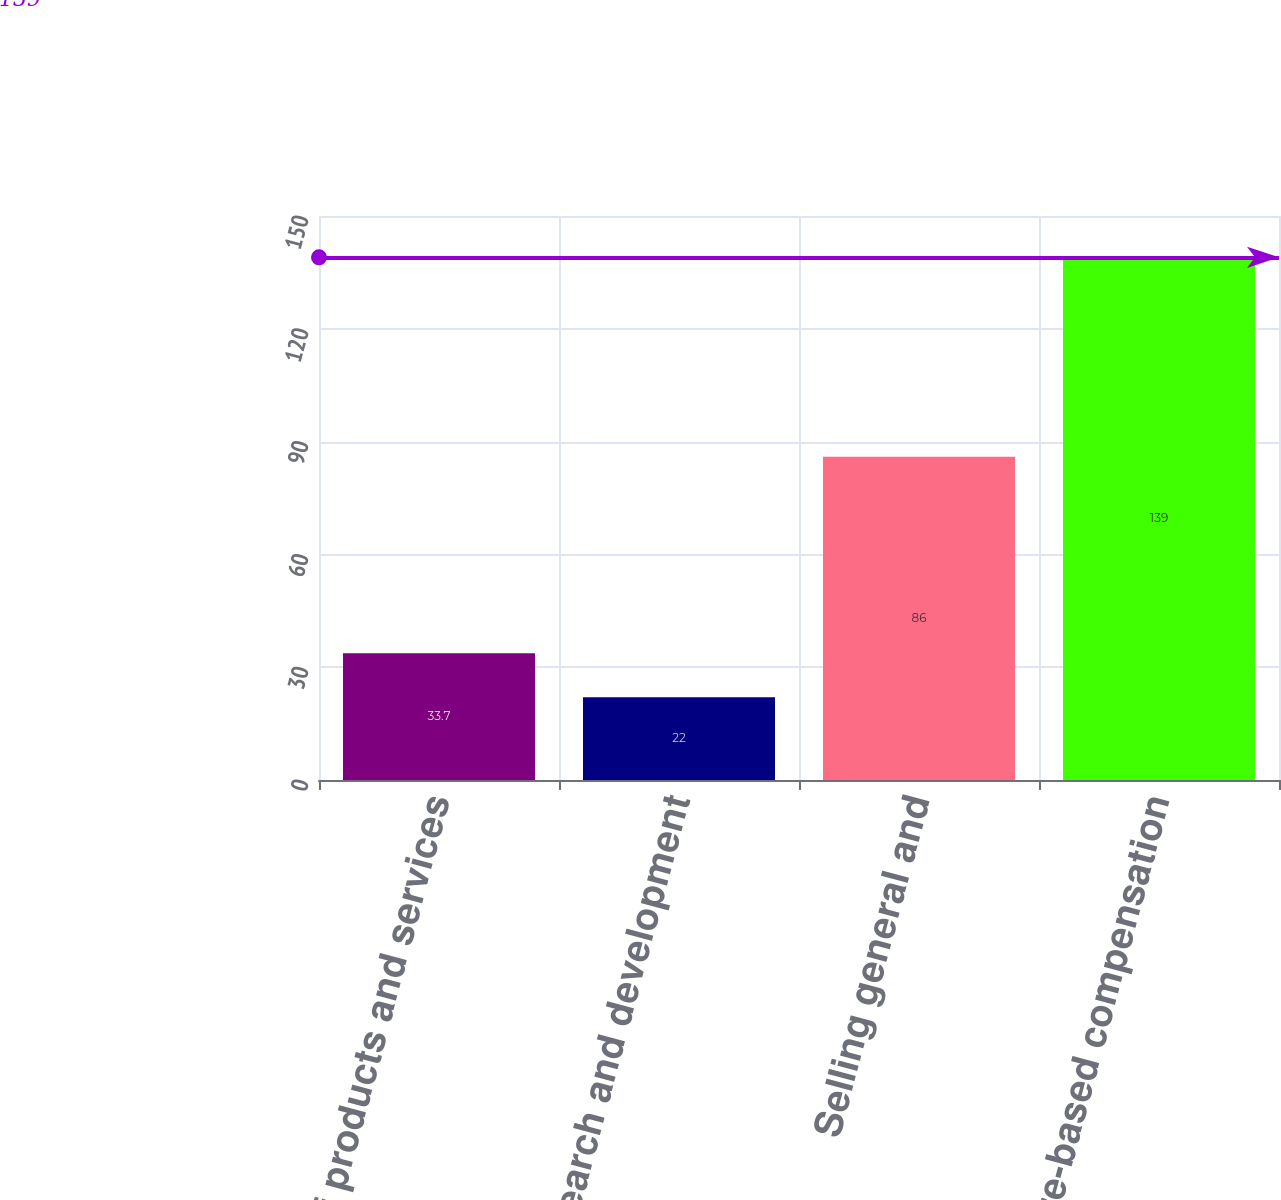<chart> <loc_0><loc_0><loc_500><loc_500><bar_chart><fcel>Cost of products and services<fcel>Research and development<fcel>Selling general and<fcel>Total share-based compensation<nl><fcel>33.7<fcel>22<fcel>86<fcel>139<nl></chart> 